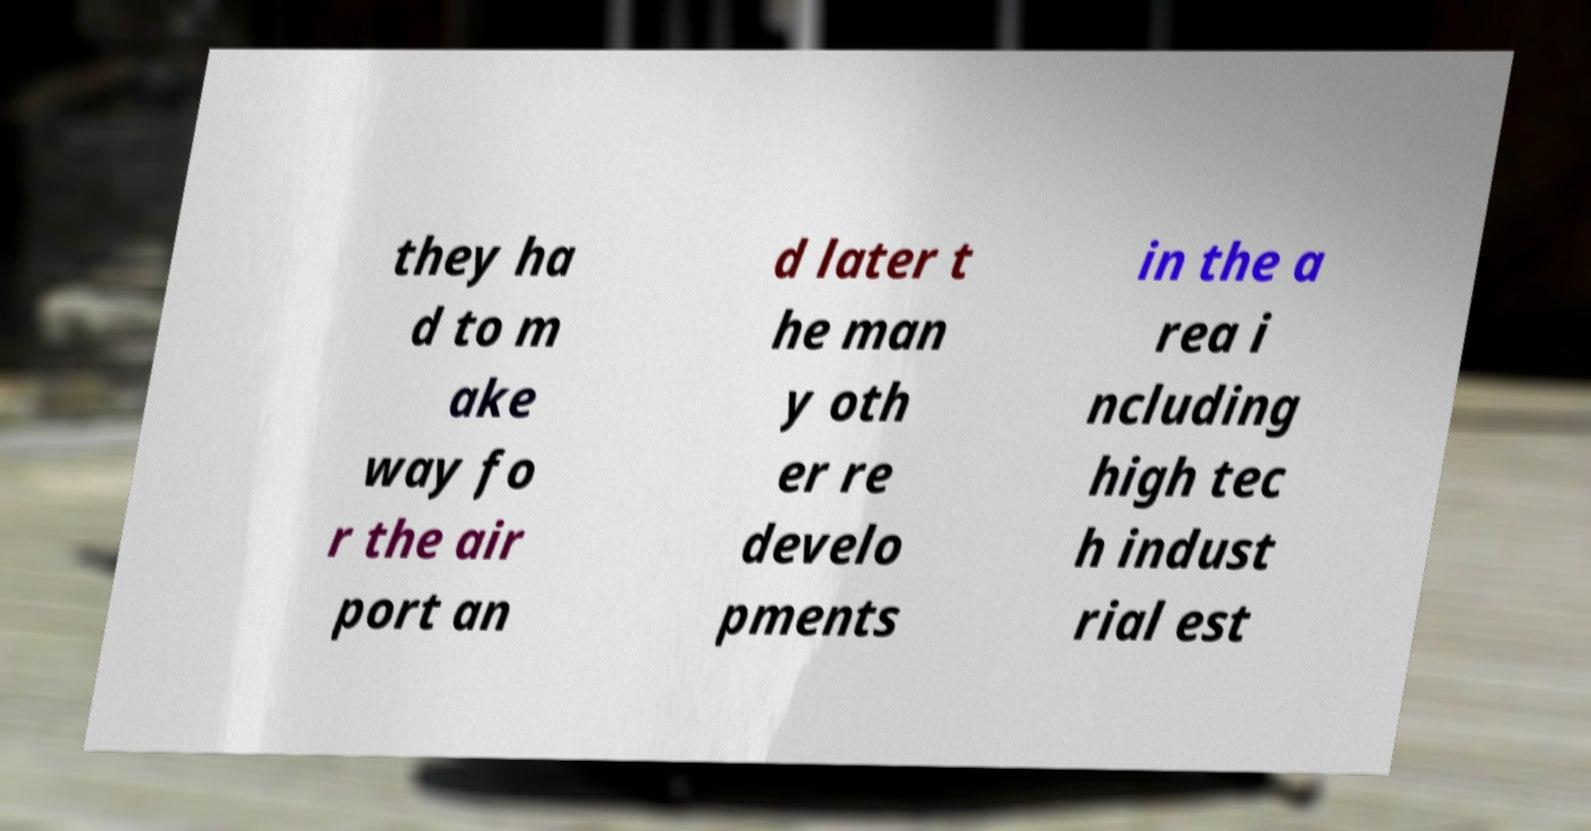Could you extract and type out the text from this image? they ha d to m ake way fo r the air port an d later t he man y oth er re develo pments in the a rea i ncluding high tec h indust rial est 